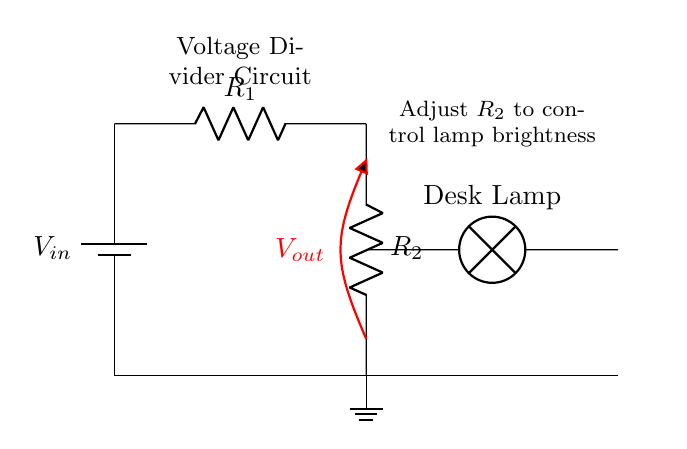What is the input voltage in the circuit? The input voltage is labeled as \( V_{in} \), indicating the source voltage supplied to the circuit.
Answer: \( V_{in} \) How many resistors are present in the circuit? There are two resistors present, labeled \( R_1 \) and \( R_2 \).
Answer: 2 What component is used to adjust the brightness of the lamp? The component used to adjust the brightness is \( R_2 \), as adjusting its resistance changes the voltage across the lamp.
Answer: \( R_2 \) What is the role of the ground in this circuit? The ground acts as a reference point for the circuit and provides a return path for the current, ensuring safely that the circuit is completed.
Answer: Reference point What is \( V_{out} \)? \( V_{out} \) is the output voltage across \( R_2 \), which is also the voltage across the desk lamp, controlling its brightness.
Answer: Output voltage How does changing \( R_2 \) affect the desk lamp? Changing \( R_2 \) alters the voltage drop across it due to the voltage divider principle, thus varying the brightness of the desk lamp.
Answer: Varies brightness What type of circuit configuration is used here? This circuit configuration is a voltage divider, which splits the input voltage across two resistors to control voltage at the output.
Answer: Voltage divider 